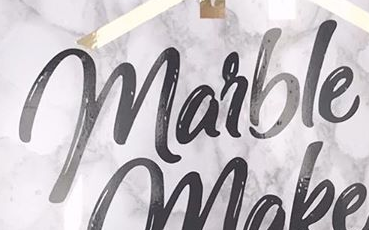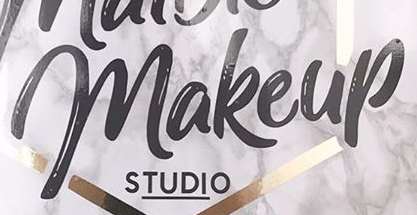What text is displayed in these images sequentially, separated by a semicolon? marble; makeup 